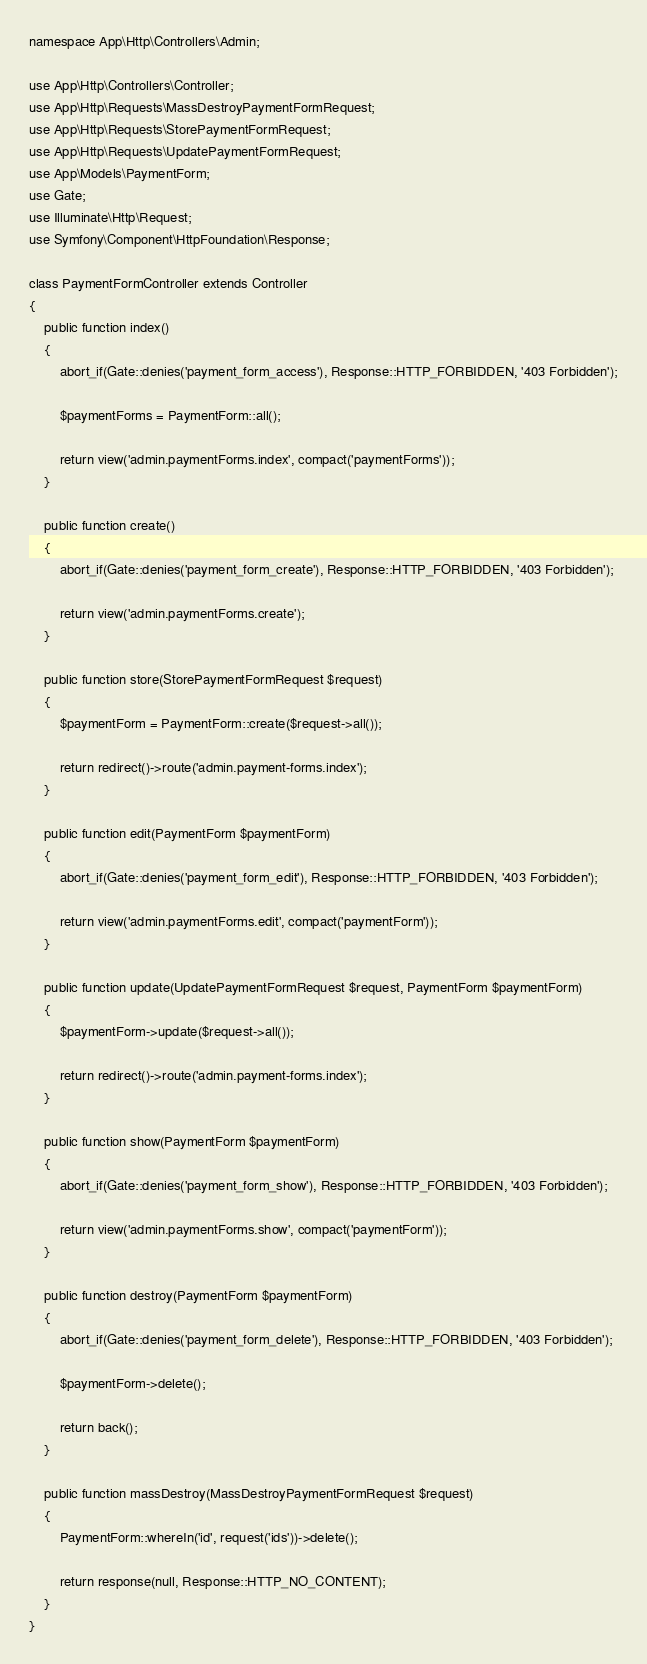<code> <loc_0><loc_0><loc_500><loc_500><_PHP_>
namespace App\Http\Controllers\Admin;

use App\Http\Controllers\Controller;
use App\Http\Requests\MassDestroyPaymentFormRequest;
use App\Http\Requests\StorePaymentFormRequest;
use App\Http\Requests\UpdatePaymentFormRequest;
use App\Models\PaymentForm;
use Gate;
use Illuminate\Http\Request;
use Symfony\Component\HttpFoundation\Response;

class PaymentFormController extends Controller
{
    public function index()
    {
        abort_if(Gate::denies('payment_form_access'), Response::HTTP_FORBIDDEN, '403 Forbidden');

        $paymentForms = PaymentForm::all();

        return view('admin.paymentForms.index', compact('paymentForms'));
    }

    public function create()
    {
        abort_if(Gate::denies('payment_form_create'), Response::HTTP_FORBIDDEN, '403 Forbidden');

        return view('admin.paymentForms.create');
    }

    public function store(StorePaymentFormRequest $request)
    {
        $paymentForm = PaymentForm::create($request->all());

        return redirect()->route('admin.payment-forms.index');
    }

    public function edit(PaymentForm $paymentForm)
    {
        abort_if(Gate::denies('payment_form_edit'), Response::HTTP_FORBIDDEN, '403 Forbidden');

        return view('admin.paymentForms.edit', compact('paymentForm'));
    }

    public function update(UpdatePaymentFormRequest $request, PaymentForm $paymentForm)
    {
        $paymentForm->update($request->all());

        return redirect()->route('admin.payment-forms.index');
    }

    public function show(PaymentForm $paymentForm)
    {
        abort_if(Gate::denies('payment_form_show'), Response::HTTP_FORBIDDEN, '403 Forbidden');

        return view('admin.paymentForms.show', compact('paymentForm'));
    }

    public function destroy(PaymentForm $paymentForm)
    {
        abort_if(Gate::denies('payment_form_delete'), Response::HTTP_FORBIDDEN, '403 Forbidden');

        $paymentForm->delete();

        return back();
    }

    public function massDestroy(MassDestroyPaymentFormRequest $request)
    {
        PaymentForm::whereIn('id', request('ids'))->delete();

        return response(null, Response::HTTP_NO_CONTENT);
    }
}
</code> 